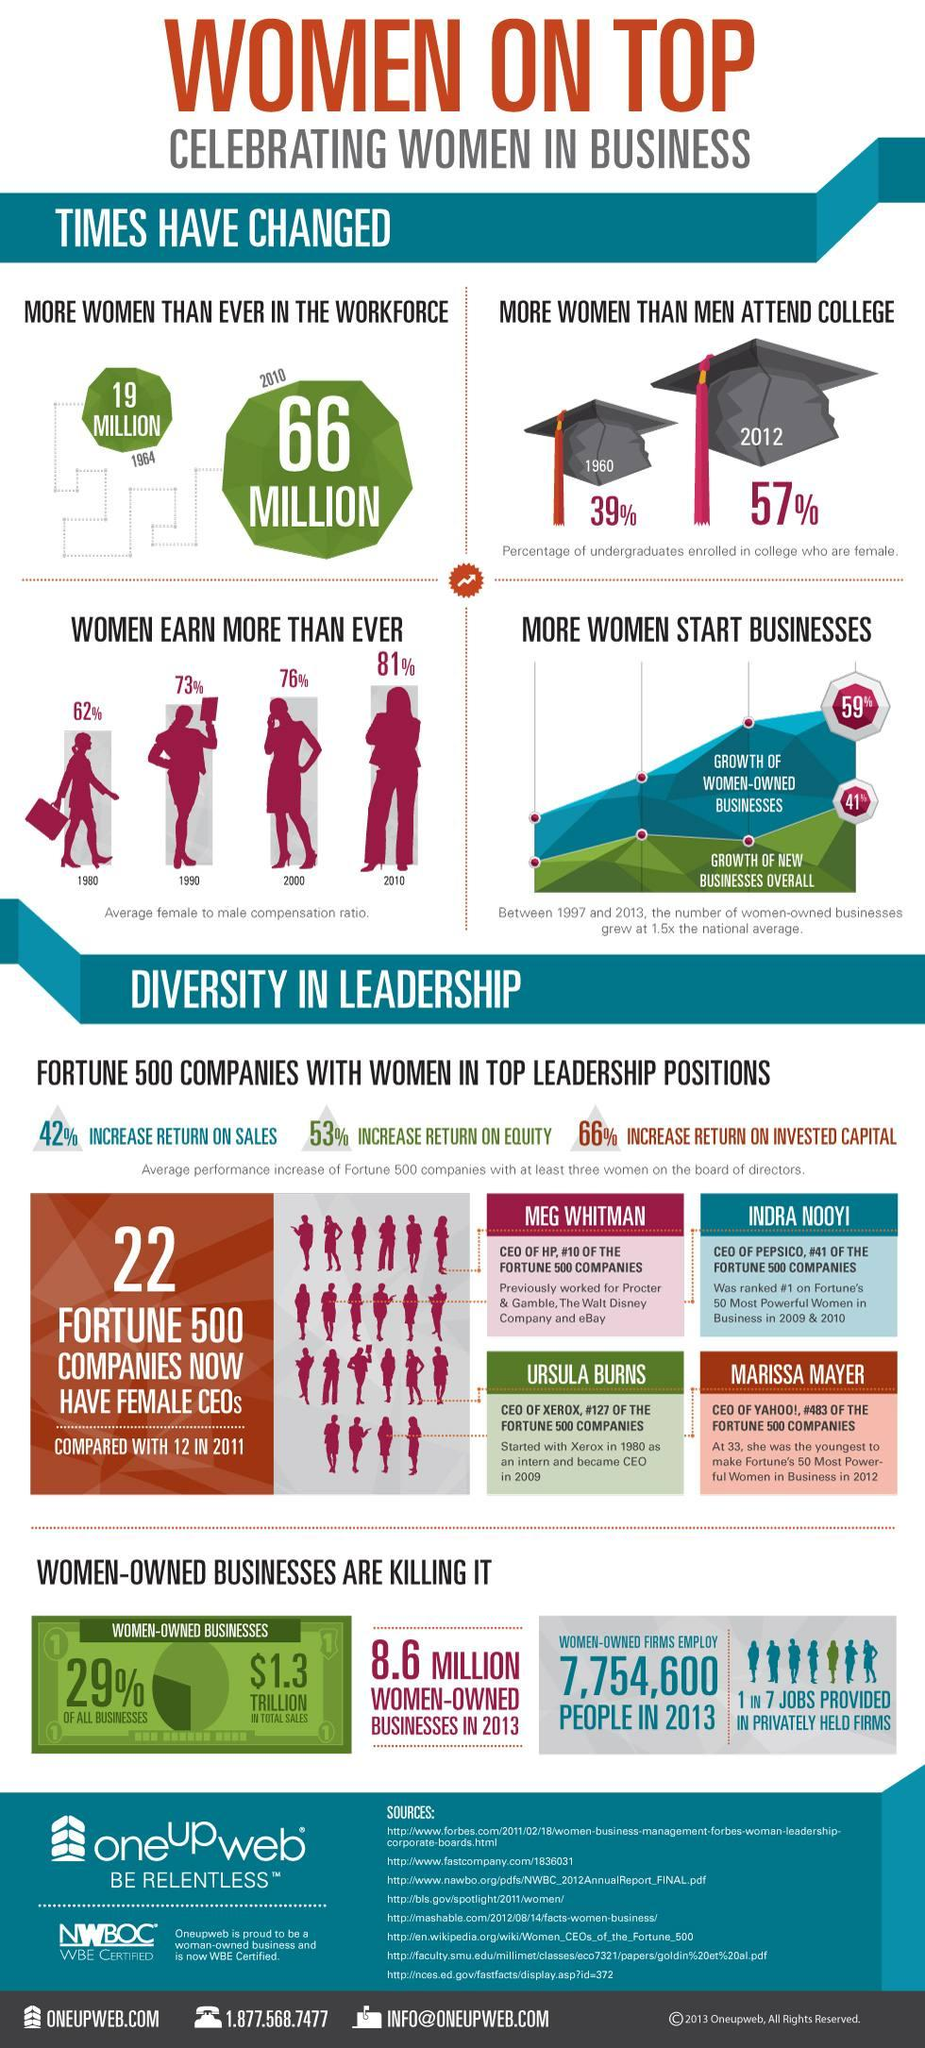Specify some key components in this picture. According to a recent study, 1 out of every 7 jobs provided in privately held firms is performed by women. In 2013, there were approximately 8.6 million women-owned businesses in the United States. The blue graph in the representation of business growth indicates the growth of women-owned businesses. In the graph depicting business growth, the green line represents the overall growth of new businesses. The increase in the number of women in the workforce from 1964 to 2010 was 47 million. 